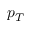Convert formula to latex. <formula><loc_0><loc_0><loc_500><loc_500>p _ { T }</formula> 